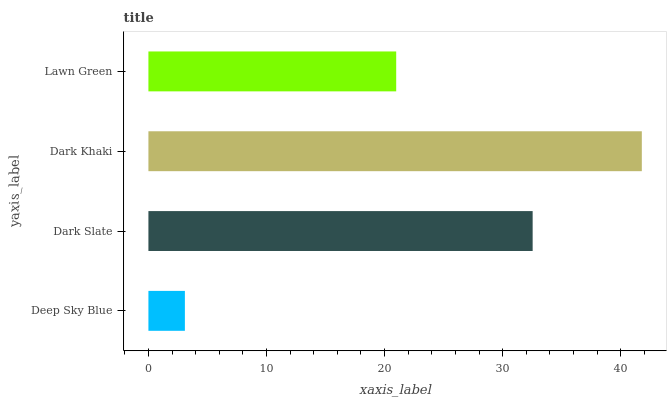Is Deep Sky Blue the minimum?
Answer yes or no. Yes. Is Dark Khaki the maximum?
Answer yes or no. Yes. Is Dark Slate the minimum?
Answer yes or no. No. Is Dark Slate the maximum?
Answer yes or no. No. Is Dark Slate greater than Deep Sky Blue?
Answer yes or no. Yes. Is Deep Sky Blue less than Dark Slate?
Answer yes or no. Yes. Is Deep Sky Blue greater than Dark Slate?
Answer yes or no. No. Is Dark Slate less than Deep Sky Blue?
Answer yes or no. No. Is Dark Slate the high median?
Answer yes or no. Yes. Is Lawn Green the low median?
Answer yes or no. Yes. Is Lawn Green the high median?
Answer yes or no. No. Is Dark Khaki the low median?
Answer yes or no. No. 